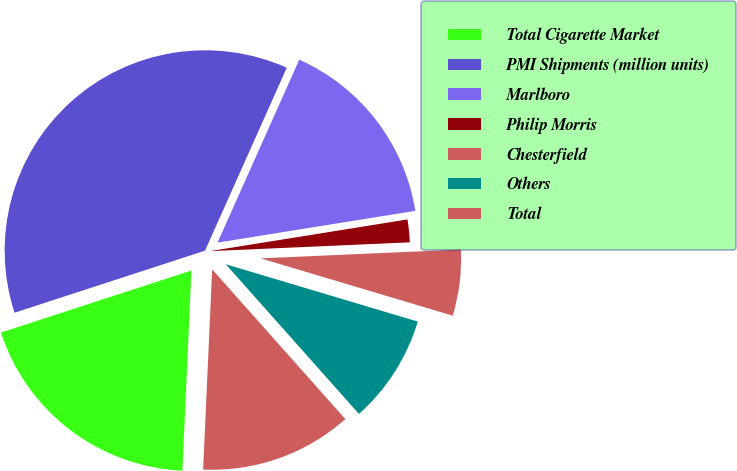Convert chart. <chart><loc_0><loc_0><loc_500><loc_500><pie_chart><fcel>Total Cigarette Market<fcel>PMI Shipments (million units)<fcel>Marlboro<fcel>Philip Morris<fcel>Chesterfield<fcel>Others<fcel>Total<nl><fcel>19.27%<fcel>36.7%<fcel>15.78%<fcel>1.83%<fcel>5.32%<fcel>8.81%<fcel>12.29%<nl></chart> 